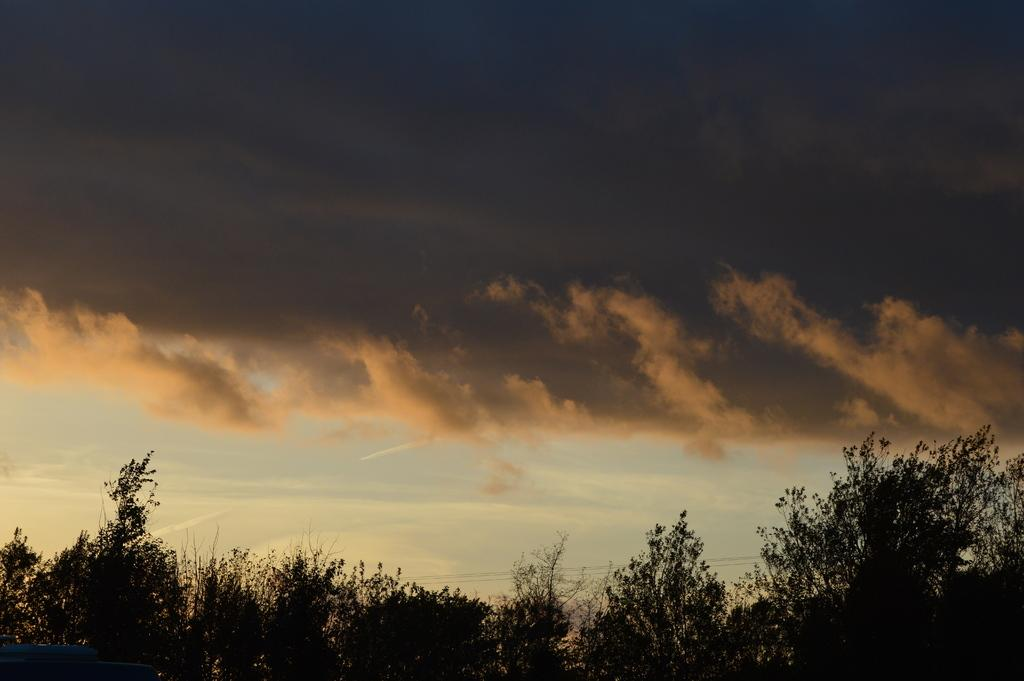What type of vegetation can be seen in the image? There are trees in the image. What part of the natural environment is visible in the image? The sky is visible in the image. What type of rice is being harvested in the image? There is no rice present in the image; it features trees and the sky. What type of flower is being used as a weapon in the war depicted in the image? There is no war or flower weapon present in the image; it only shows trees and the sky. 